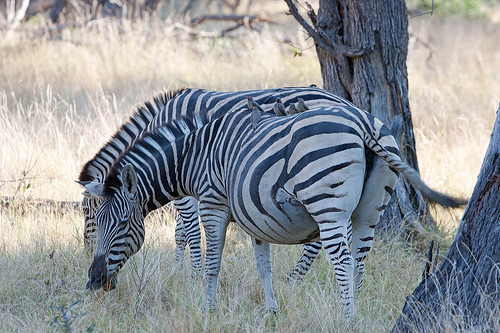How many zebras are there? There are two zebras in the image. They can be identified by their distinct black and white striped patterns, which are unique to each individual much like fingerprints. 